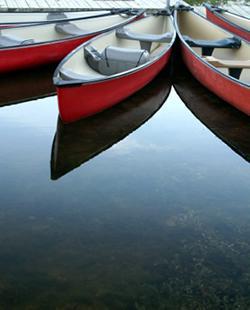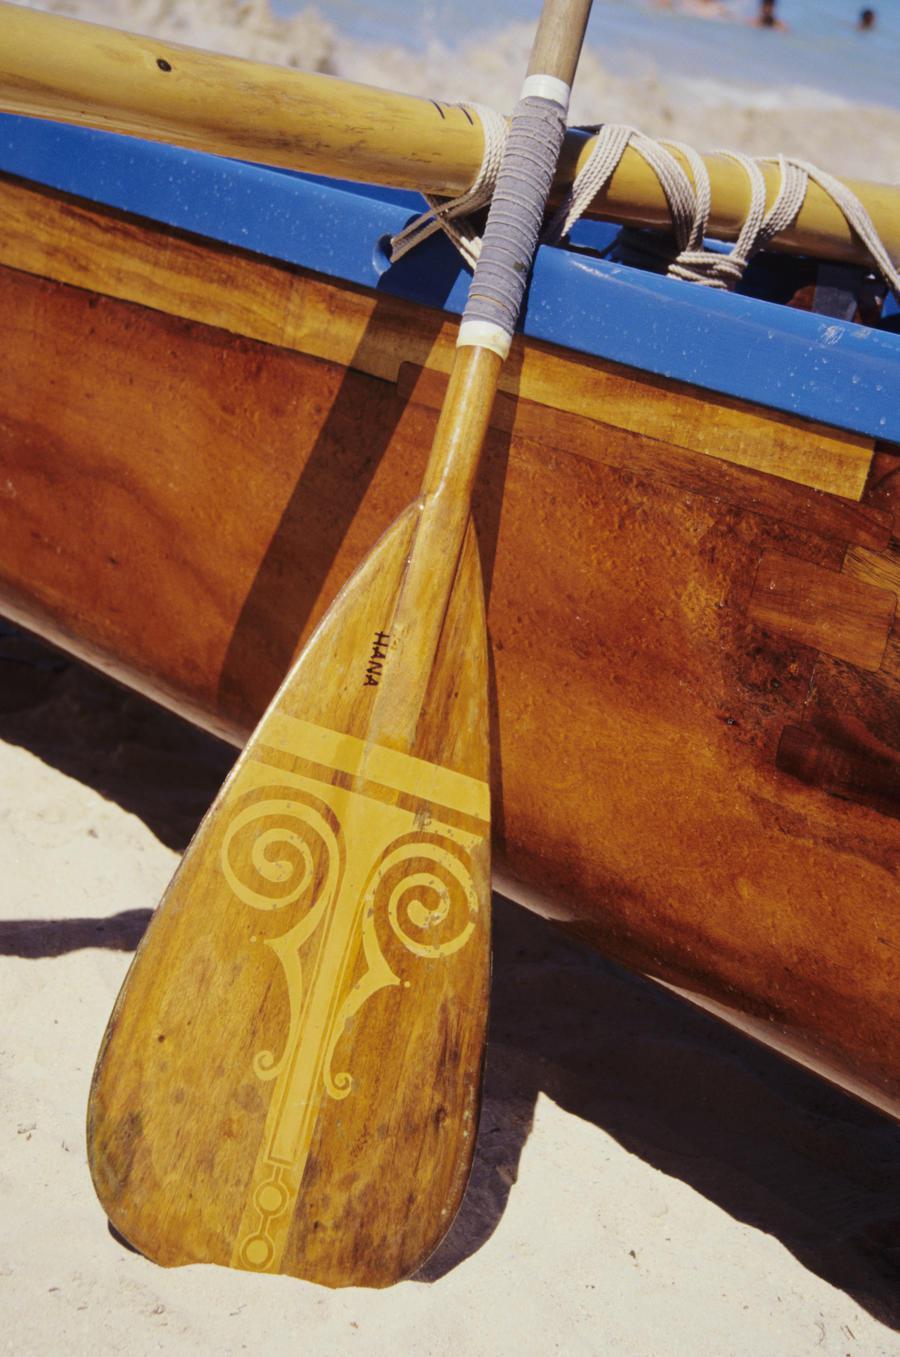The first image is the image on the left, the second image is the image on the right. Analyze the images presented: Is the assertion "One image shows at least three empty red canoes parked close together on water, and the other image includes at least one oar." valid? Answer yes or no. Yes. 